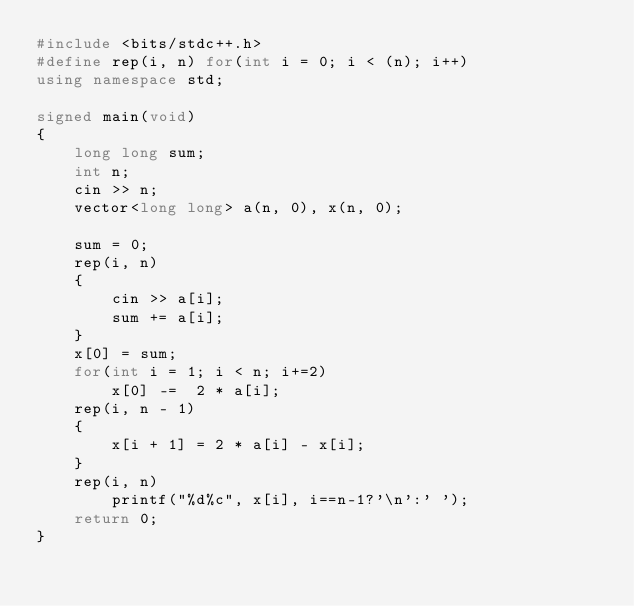<code> <loc_0><loc_0><loc_500><loc_500><_C++_>#include <bits/stdc++.h>
#define rep(i, n) for(int i = 0; i < (n); i++)
using namespace std;

signed main(void)
{
	long long sum;
	int n;
	cin >> n;
	vector<long long> a(n, 0), x(n, 0);

	sum = 0;
	rep(i, n)
	{
		cin >> a[i];
		sum += a[i];
	}
	x[0] = sum;
	for(int i = 1; i < n; i+=2)
		x[0] -=  2 * a[i]; 
	rep(i, n - 1)
	{
		x[i + 1] = 2 * a[i] - x[i];
	}
	rep(i, n)
		printf("%d%c", x[i], i==n-1?'\n':' ');
	return 0;
}
</code> 